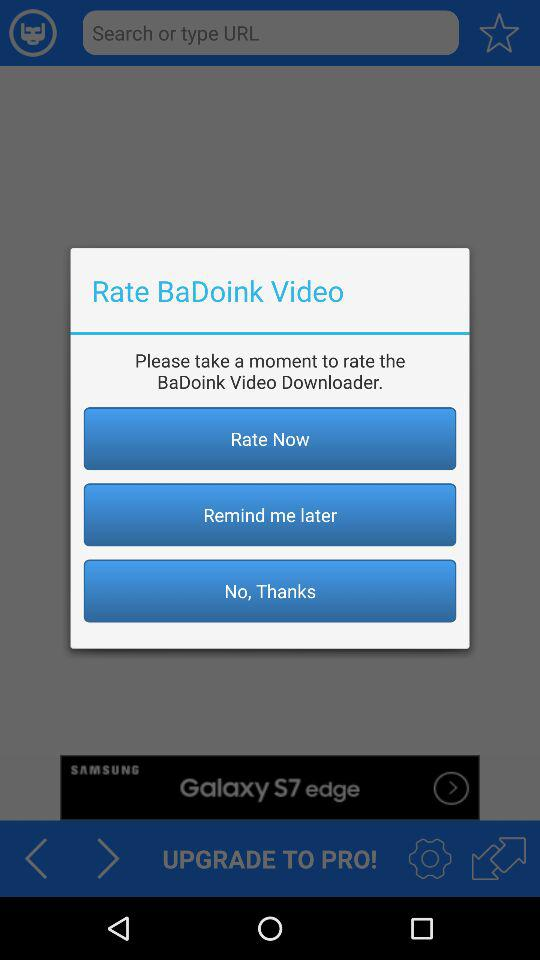Which rate is selected?
When the provided information is insufficient, respond with <no answer>. <no answer> 